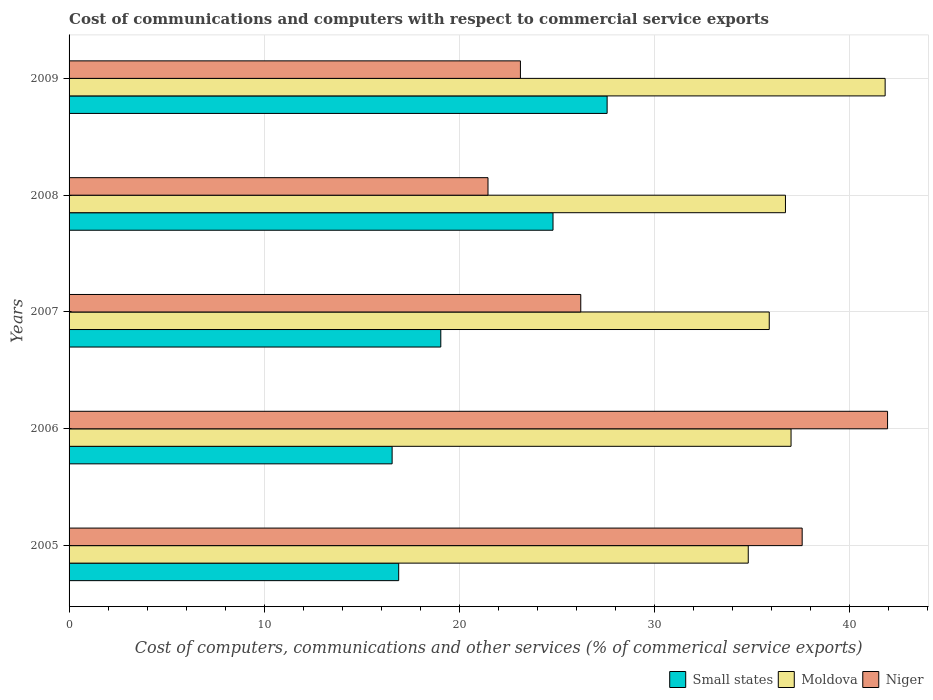How many different coloured bars are there?
Make the answer very short. 3. How many bars are there on the 3rd tick from the top?
Provide a short and direct response. 3. How many bars are there on the 4th tick from the bottom?
Make the answer very short. 3. What is the label of the 2nd group of bars from the top?
Provide a short and direct response. 2008. In how many cases, is the number of bars for a given year not equal to the number of legend labels?
Your response must be concise. 0. What is the cost of communications and computers in Niger in 2005?
Provide a succinct answer. 37.59. Across all years, what is the maximum cost of communications and computers in Moldova?
Give a very brief answer. 41.84. Across all years, what is the minimum cost of communications and computers in Niger?
Provide a succinct answer. 21.48. In which year was the cost of communications and computers in Small states maximum?
Provide a short and direct response. 2009. What is the total cost of communications and computers in Niger in the graph?
Make the answer very short. 150.41. What is the difference between the cost of communications and computers in Small states in 2008 and that in 2009?
Keep it short and to the point. -2.77. What is the difference between the cost of communications and computers in Small states in 2009 and the cost of communications and computers in Niger in 2007?
Keep it short and to the point. 1.35. What is the average cost of communications and computers in Small states per year?
Make the answer very short. 20.98. In the year 2007, what is the difference between the cost of communications and computers in Small states and cost of communications and computers in Niger?
Ensure brevity in your answer.  -7.18. What is the ratio of the cost of communications and computers in Small states in 2007 to that in 2009?
Provide a short and direct response. 0.69. What is the difference between the highest and the second highest cost of communications and computers in Small states?
Provide a short and direct response. 2.77. What is the difference between the highest and the lowest cost of communications and computers in Niger?
Provide a short and direct response. 20.49. In how many years, is the cost of communications and computers in Moldova greater than the average cost of communications and computers in Moldova taken over all years?
Your response must be concise. 1. Is the sum of the cost of communications and computers in Moldova in 2006 and 2009 greater than the maximum cost of communications and computers in Small states across all years?
Offer a terse response. Yes. What does the 1st bar from the top in 2006 represents?
Make the answer very short. Niger. What does the 3rd bar from the bottom in 2008 represents?
Provide a succinct answer. Niger. Is it the case that in every year, the sum of the cost of communications and computers in Moldova and cost of communications and computers in Small states is greater than the cost of communications and computers in Niger?
Offer a very short reply. Yes. Are all the bars in the graph horizontal?
Provide a short and direct response. Yes. What is the difference between two consecutive major ticks on the X-axis?
Make the answer very short. 10. Does the graph contain any zero values?
Your response must be concise. No. How many legend labels are there?
Offer a very short reply. 3. How are the legend labels stacked?
Make the answer very short. Horizontal. What is the title of the graph?
Offer a very short reply. Cost of communications and computers with respect to commercial service exports. Does "St. Martin (French part)" appear as one of the legend labels in the graph?
Provide a succinct answer. No. What is the label or title of the X-axis?
Provide a short and direct response. Cost of computers, communications and other services (% of commerical service exports). What is the label or title of the Y-axis?
Offer a terse response. Years. What is the Cost of computers, communications and other services (% of commerical service exports) in Small states in 2005?
Your response must be concise. 16.9. What is the Cost of computers, communications and other services (% of commerical service exports) of Moldova in 2005?
Ensure brevity in your answer.  34.82. What is the Cost of computers, communications and other services (% of commerical service exports) of Niger in 2005?
Your response must be concise. 37.59. What is the Cost of computers, communications and other services (% of commerical service exports) of Small states in 2006?
Make the answer very short. 16.56. What is the Cost of computers, communications and other services (% of commerical service exports) in Moldova in 2006?
Keep it short and to the point. 37.02. What is the Cost of computers, communications and other services (% of commerical service exports) in Niger in 2006?
Your answer should be compact. 41.97. What is the Cost of computers, communications and other services (% of commerical service exports) in Small states in 2007?
Your response must be concise. 19.06. What is the Cost of computers, communications and other services (% of commerical service exports) in Moldova in 2007?
Your answer should be compact. 35.9. What is the Cost of computers, communications and other services (% of commerical service exports) in Niger in 2007?
Give a very brief answer. 26.24. What is the Cost of computers, communications and other services (% of commerical service exports) in Small states in 2008?
Provide a short and direct response. 24.81. What is the Cost of computers, communications and other services (% of commerical service exports) of Moldova in 2008?
Your answer should be very brief. 36.73. What is the Cost of computers, communications and other services (% of commerical service exports) of Niger in 2008?
Give a very brief answer. 21.48. What is the Cost of computers, communications and other services (% of commerical service exports) in Small states in 2009?
Provide a succinct answer. 27.59. What is the Cost of computers, communications and other services (% of commerical service exports) in Moldova in 2009?
Your answer should be very brief. 41.84. What is the Cost of computers, communications and other services (% of commerical service exports) in Niger in 2009?
Your response must be concise. 23.14. Across all years, what is the maximum Cost of computers, communications and other services (% of commerical service exports) in Small states?
Offer a very short reply. 27.59. Across all years, what is the maximum Cost of computers, communications and other services (% of commerical service exports) in Moldova?
Keep it short and to the point. 41.84. Across all years, what is the maximum Cost of computers, communications and other services (% of commerical service exports) in Niger?
Make the answer very short. 41.97. Across all years, what is the minimum Cost of computers, communications and other services (% of commerical service exports) in Small states?
Your answer should be compact. 16.56. Across all years, what is the minimum Cost of computers, communications and other services (% of commerical service exports) of Moldova?
Your answer should be very brief. 34.82. Across all years, what is the minimum Cost of computers, communications and other services (% of commerical service exports) of Niger?
Your response must be concise. 21.48. What is the total Cost of computers, communications and other services (% of commerical service exports) of Small states in the graph?
Offer a terse response. 104.92. What is the total Cost of computers, communications and other services (% of commerical service exports) in Moldova in the graph?
Make the answer very short. 186.31. What is the total Cost of computers, communications and other services (% of commerical service exports) in Niger in the graph?
Provide a short and direct response. 150.41. What is the difference between the Cost of computers, communications and other services (% of commerical service exports) in Small states in 2005 and that in 2006?
Offer a terse response. 0.34. What is the difference between the Cost of computers, communications and other services (% of commerical service exports) of Moldova in 2005 and that in 2006?
Give a very brief answer. -2.19. What is the difference between the Cost of computers, communications and other services (% of commerical service exports) in Niger in 2005 and that in 2006?
Keep it short and to the point. -4.38. What is the difference between the Cost of computers, communications and other services (% of commerical service exports) in Small states in 2005 and that in 2007?
Offer a terse response. -2.16. What is the difference between the Cost of computers, communications and other services (% of commerical service exports) of Moldova in 2005 and that in 2007?
Give a very brief answer. -1.08. What is the difference between the Cost of computers, communications and other services (% of commerical service exports) in Niger in 2005 and that in 2007?
Your response must be concise. 11.35. What is the difference between the Cost of computers, communications and other services (% of commerical service exports) of Small states in 2005 and that in 2008?
Give a very brief answer. -7.91. What is the difference between the Cost of computers, communications and other services (% of commerical service exports) of Moldova in 2005 and that in 2008?
Provide a succinct answer. -1.91. What is the difference between the Cost of computers, communications and other services (% of commerical service exports) in Niger in 2005 and that in 2008?
Make the answer very short. 16.11. What is the difference between the Cost of computers, communications and other services (% of commerical service exports) of Small states in 2005 and that in 2009?
Keep it short and to the point. -10.69. What is the difference between the Cost of computers, communications and other services (% of commerical service exports) in Moldova in 2005 and that in 2009?
Your answer should be compact. -7.02. What is the difference between the Cost of computers, communications and other services (% of commerical service exports) in Niger in 2005 and that in 2009?
Offer a terse response. 14.45. What is the difference between the Cost of computers, communications and other services (% of commerical service exports) in Small states in 2006 and that in 2007?
Ensure brevity in your answer.  -2.5. What is the difference between the Cost of computers, communications and other services (% of commerical service exports) in Moldova in 2006 and that in 2007?
Give a very brief answer. 1.12. What is the difference between the Cost of computers, communications and other services (% of commerical service exports) in Niger in 2006 and that in 2007?
Offer a very short reply. 15.73. What is the difference between the Cost of computers, communications and other services (% of commerical service exports) of Small states in 2006 and that in 2008?
Make the answer very short. -8.25. What is the difference between the Cost of computers, communications and other services (% of commerical service exports) of Moldova in 2006 and that in 2008?
Your answer should be compact. 0.29. What is the difference between the Cost of computers, communications and other services (% of commerical service exports) of Niger in 2006 and that in 2008?
Your response must be concise. 20.49. What is the difference between the Cost of computers, communications and other services (% of commerical service exports) in Small states in 2006 and that in 2009?
Offer a terse response. -11.02. What is the difference between the Cost of computers, communications and other services (% of commerical service exports) of Moldova in 2006 and that in 2009?
Your answer should be compact. -4.82. What is the difference between the Cost of computers, communications and other services (% of commerical service exports) of Niger in 2006 and that in 2009?
Provide a succinct answer. 18.82. What is the difference between the Cost of computers, communications and other services (% of commerical service exports) in Small states in 2007 and that in 2008?
Your answer should be very brief. -5.75. What is the difference between the Cost of computers, communications and other services (% of commerical service exports) of Moldova in 2007 and that in 2008?
Your answer should be compact. -0.83. What is the difference between the Cost of computers, communications and other services (% of commerical service exports) of Niger in 2007 and that in 2008?
Your answer should be compact. 4.76. What is the difference between the Cost of computers, communications and other services (% of commerical service exports) in Small states in 2007 and that in 2009?
Ensure brevity in your answer.  -8.53. What is the difference between the Cost of computers, communications and other services (% of commerical service exports) of Moldova in 2007 and that in 2009?
Your answer should be compact. -5.94. What is the difference between the Cost of computers, communications and other services (% of commerical service exports) in Niger in 2007 and that in 2009?
Keep it short and to the point. 3.09. What is the difference between the Cost of computers, communications and other services (% of commerical service exports) in Small states in 2008 and that in 2009?
Keep it short and to the point. -2.77. What is the difference between the Cost of computers, communications and other services (% of commerical service exports) of Moldova in 2008 and that in 2009?
Your response must be concise. -5.11. What is the difference between the Cost of computers, communications and other services (% of commerical service exports) of Niger in 2008 and that in 2009?
Your response must be concise. -1.66. What is the difference between the Cost of computers, communications and other services (% of commerical service exports) in Small states in 2005 and the Cost of computers, communications and other services (% of commerical service exports) in Moldova in 2006?
Keep it short and to the point. -20.12. What is the difference between the Cost of computers, communications and other services (% of commerical service exports) in Small states in 2005 and the Cost of computers, communications and other services (% of commerical service exports) in Niger in 2006?
Give a very brief answer. -25.07. What is the difference between the Cost of computers, communications and other services (% of commerical service exports) of Moldova in 2005 and the Cost of computers, communications and other services (% of commerical service exports) of Niger in 2006?
Make the answer very short. -7.14. What is the difference between the Cost of computers, communications and other services (% of commerical service exports) of Small states in 2005 and the Cost of computers, communications and other services (% of commerical service exports) of Moldova in 2007?
Make the answer very short. -19. What is the difference between the Cost of computers, communications and other services (% of commerical service exports) of Small states in 2005 and the Cost of computers, communications and other services (% of commerical service exports) of Niger in 2007?
Provide a succinct answer. -9.34. What is the difference between the Cost of computers, communications and other services (% of commerical service exports) of Moldova in 2005 and the Cost of computers, communications and other services (% of commerical service exports) of Niger in 2007?
Keep it short and to the point. 8.59. What is the difference between the Cost of computers, communications and other services (% of commerical service exports) of Small states in 2005 and the Cost of computers, communications and other services (% of commerical service exports) of Moldova in 2008?
Make the answer very short. -19.83. What is the difference between the Cost of computers, communications and other services (% of commerical service exports) of Small states in 2005 and the Cost of computers, communications and other services (% of commerical service exports) of Niger in 2008?
Offer a very short reply. -4.58. What is the difference between the Cost of computers, communications and other services (% of commerical service exports) of Moldova in 2005 and the Cost of computers, communications and other services (% of commerical service exports) of Niger in 2008?
Make the answer very short. 13.34. What is the difference between the Cost of computers, communications and other services (% of commerical service exports) of Small states in 2005 and the Cost of computers, communications and other services (% of commerical service exports) of Moldova in 2009?
Your response must be concise. -24.94. What is the difference between the Cost of computers, communications and other services (% of commerical service exports) of Small states in 2005 and the Cost of computers, communications and other services (% of commerical service exports) of Niger in 2009?
Your answer should be very brief. -6.24. What is the difference between the Cost of computers, communications and other services (% of commerical service exports) in Moldova in 2005 and the Cost of computers, communications and other services (% of commerical service exports) in Niger in 2009?
Provide a short and direct response. 11.68. What is the difference between the Cost of computers, communications and other services (% of commerical service exports) of Small states in 2006 and the Cost of computers, communications and other services (% of commerical service exports) of Moldova in 2007?
Your answer should be very brief. -19.34. What is the difference between the Cost of computers, communications and other services (% of commerical service exports) in Small states in 2006 and the Cost of computers, communications and other services (% of commerical service exports) in Niger in 2007?
Keep it short and to the point. -9.67. What is the difference between the Cost of computers, communications and other services (% of commerical service exports) in Moldova in 2006 and the Cost of computers, communications and other services (% of commerical service exports) in Niger in 2007?
Make the answer very short. 10.78. What is the difference between the Cost of computers, communications and other services (% of commerical service exports) of Small states in 2006 and the Cost of computers, communications and other services (% of commerical service exports) of Moldova in 2008?
Keep it short and to the point. -20.17. What is the difference between the Cost of computers, communications and other services (% of commerical service exports) in Small states in 2006 and the Cost of computers, communications and other services (% of commerical service exports) in Niger in 2008?
Your answer should be very brief. -4.92. What is the difference between the Cost of computers, communications and other services (% of commerical service exports) in Moldova in 2006 and the Cost of computers, communications and other services (% of commerical service exports) in Niger in 2008?
Make the answer very short. 15.54. What is the difference between the Cost of computers, communications and other services (% of commerical service exports) in Small states in 2006 and the Cost of computers, communications and other services (% of commerical service exports) in Moldova in 2009?
Provide a succinct answer. -25.28. What is the difference between the Cost of computers, communications and other services (% of commerical service exports) of Small states in 2006 and the Cost of computers, communications and other services (% of commerical service exports) of Niger in 2009?
Your answer should be compact. -6.58. What is the difference between the Cost of computers, communications and other services (% of commerical service exports) in Moldova in 2006 and the Cost of computers, communications and other services (% of commerical service exports) in Niger in 2009?
Provide a succinct answer. 13.88. What is the difference between the Cost of computers, communications and other services (% of commerical service exports) of Small states in 2007 and the Cost of computers, communications and other services (% of commerical service exports) of Moldova in 2008?
Keep it short and to the point. -17.67. What is the difference between the Cost of computers, communications and other services (% of commerical service exports) in Small states in 2007 and the Cost of computers, communications and other services (% of commerical service exports) in Niger in 2008?
Keep it short and to the point. -2.42. What is the difference between the Cost of computers, communications and other services (% of commerical service exports) of Moldova in 2007 and the Cost of computers, communications and other services (% of commerical service exports) of Niger in 2008?
Offer a very short reply. 14.42. What is the difference between the Cost of computers, communications and other services (% of commerical service exports) of Small states in 2007 and the Cost of computers, communications and other services (% of commerical service exports) of Moldova in 2009?
Provide a short and direct response. -22.78. What is the difference between the Cost of computers, communications and other services (% of commerical service exports) in Small states in 2007 and the Cost of computers, communications and other services (% of commerical service exports) in Niger in 2009?
Ensure brevity in your answer.  -4.08. What is the difference between the Cost of computers, communications and other services (% of commerical service exports) of Moldova in 2007 and the Cost of computers, communications and other services (% of commerical service exports) of Niger in 2009?
Your answer should be very brief. 12.76. What is the difference between the Cost of computers, communications and other services (% of commerical service exports) of Small states in 2008 and the Cost of computers, communications and other services (% of commerical service exports) of Moldova in 2009?
Your response must be concise. -17.03. What is the difference between the Cost of computers, communications and other services (% of commerical service exports) of Small states in 2008 and the Cost of computers, communications and other services (% of commerical service exports) of Niger in 2009?
Your answer should be compact. 1.67. What is the difference between the Cost of computers, communications and other services (% of commerical service exports) of Moldova in 2008 and the Cost of computers, communications and other services (% of commerical service exports) of Niger in 2009?
Ensure brevity in your answer.  13.59. What is the average Cost of computers, communications and other services (% of commerical service exports) of Small states per year?
Your answer should be very brief. 20.98. What is the average Cost of computers, communications and other services (% of commerical service exports) in Moldova per year?
Your answer should be very brief. 37.26. What is the average Cost of computers, communications and other services (% of commerical service exports) of Niger per year?
Your answer should be very brief. 30.08. In the year 2005, what is the difference between the Cost of computers, communications and other services (% of commerical service exports) of Small states and Cost of computers, communications and other services (% of commerical service exports) of Moldova?
Provide a short and direct response. -17.92. In the year 2005, what is the difference between the Cost of computers, communications and other services (% of commerical service exports) of Small states and Cost of computers, communications and other services (% of commerical service exports) of Niger?
Make the answer very short. -20.69. In the year 2005, what is the difference between the Cost of computers, communications and other services (% of commerical service exports) of Moldova and Cost of computers, communications and other services (% of commerical service exports) of Niger?
Ensure brevity in your answer.  -2.76. In the year 2006, what is the difference between the Cost of computers, communications and other services (% of commerical service exports) in Small states and Cost of computers, communications and other services (% of commerical service exports) in Moldova?
Provide a succinct answer. -20.45. In the year 2006, what is the difference between the Cost of computers, communications and other services (% of commerical service exports) of Small states and Cost of computers, communications and other services (% of commerical service exports) of Niger?
Your answer should be very brief. -25.4. In the year 2006, what is the difference between the Cost of computers, communications and other services (% of commerical service exports) in Moldova and Cost of computers, communications and other services (% of commerical service exports) in Niger?
Your response must be concise. -4.95. In the year 2007, what is the difference between the Cost of computers, communications and other services (% of commerical service exports) in Small states and Cost of computers, communications and other services (% of commerical service exports) in Moldova?
Provide a succinct answer. -16.84. In the year 2007, what is the difference between the Cost of computers, communications and other services (% of commerical service exports) of Small states and Cost of computers, communications and other services (% of commerical service exports) of Niger?
Keep it short and to the point. -7.18. In the year 2007, what is the difference between the Cost of computers, communications and other services (% of commerical service exports) in Moldova and Cost of computers, communications and other services (% of commerical service exports) in Niger?
Provide a succinct answer. 9.66. In the year 2008, what is the difference between the Cost of computers, communications and other services (% of commerical service exports) of Small states and Cost of computers, communications and other services (% of commerical service exports) of Moldova?
Your answer should be compact. -11.92. In the year 2008, what is the difference between the Cost of computers, communications and other services (% of commerical service exports) of Small states and Cost of computers, communications and other services (% of commerical service exports) of Niger?
Provide a short and direct response. 3.33. In the year 2008, what is the difference between the Cost of computers, communications and other services (% of commerical service exports) of Moldova and Cost of computers, communications and other services (% of commerical service exports) of Niger?
Offer a terse response. 15.25. In the year 2009, what is the difference between the Cost of computers, communications and other services (% of commerical service exports) in Small states and Cost of computers, communications and other services (% of commerical service exports) in Moldova?
Offer a terse response. -14.25. In the year 2009, what is the difference between the Cost of computers, communications and other services (% of commerical service exports) in Small states and Cost of computers, communications and other services (% of commerical service exports) in Niger?
Give a very brief answer. 4.45. In the year 2009, what is the difference between the Cost of computers, communications and other services (% of commerical service exports) of Moldova and Cost of computers, communications and other services (% of commerical service exports) of Niger?
Your response must be concise. 18.7. What is the ratio of the Cost of computers, communications and other services (% of commerical service exports) of Small states in 2005 to that in 2006?
Keep it short and to the point. 1.02. What is the ratio of the Cost of computers, communications and other services (% of commerical service exports) in Moldova in 2005 to that in 2006?
Provide a succinct answer. 0.94. What is the ratio of the Cost of computers, communications and other services (% of commerical service exports) of Niger in 2005 to that in 2006?
Keep it short and to the point. 0.9. What is the ratio of the Cost of computers, communications and other services (% of commerical service exports) of Small states in 2005 to that in 2007?
Give a very brief answer. 0.89. What is the ratio of the Cost of computers, communications and other services (% of commerical service exports) in Moldova in 2005 to that in 2007?
Provide a short and direct response. 0.97. What is the ratio of the Cost of computers, communications and other services (% of commerical service exports) in Niger in 2005 to that in 2007?
Your answer should be compact. 1.43. What is the ratio of the Cost of computers, communications and other services (% of commerical service exports) of Small states in 2005 to that in 2008?
Provide a succinct answer. 0.68. What is the ratio of the Cost of computers, communications and other services (% of commerical service exports) of Moldova in 2005 to that in 2008?
Provide a short and direct response. 0.95. What is the ratio of the Cost of computers, communications and other services (% of commerical service exports) in Niger in 2005 to that in 2008?
Provide a succinct answer. 1.75. What is the ratio of the Cost of computers, communications and other services (% of commerical service exports) of Small states in 2005 to that in 2009?
Make the answer very short. 0.61. What is the ratio of the Cost of computers, communications and other services (% of commerical service exports) of Moldova in 2005 to that in 2009?
Keep it short and to the point. 0.83. What is the ratio of the Cost of computers, communications and other services (% of commerical service exports) of Niger in 2005 to that in 2009?
Give a very brief answer. 1.62. What is the ratio of the Cost of computers, communications and other services (% of commerical service exports) of Small states in 2006 to that in 2007?
Your answer should be very brief. 0.87. What is the ratio of the Cost of computers, communications and other services (% of commerical service exports) of Moldova in 2006 to that in 2007?
Give a very brief answer. 1.03. What is the ratio of the Cost of computers, communications and other services (% of commerical service exports) in Niger in 2006 to that in 2007?
Make the answer very short. 1.6. What is the ratio of the Cost of computers, communications and other services (% of commerical service exports) of Small states in 2006 to that in 2008?
Offer a terse response. 0.67. What is the ratio of the Cost of computers, communications and other services (% of commerical service exports) of Niger in 2006 to that in 2008?
Keep it short and to the point. 1.95. What is the ratio of the Cost of computers, communications and other services (% of commerical service exports) of Small states in 2006 to that in 2009?
Keep it short and to the point. 0.6. What is the ratio of the Cost of computers, communications and other services (% of commerical service exports) of Moldova in 2006 to that in 2009?
Your answer should be very brief. 0.88. What is the ratio of the Cost of computers, communications and other services (% of commerical service exports) of Niger in 2006 to that in 2009?
Make the answer very short. 1.81. What is the ratio of the Cost of computers, communications and other services (% of commerical service exports) in Small states in 2007 to that in 2008?
Make the answer very short. 0.77. What is the ratio of the Cost of computers, communications and other services (% of commerical service exports) in Moldova in 2007 to that in 2008?
Provide a succinct answer. 0.98. What is the ratio of the Cost of computers, communications and other services (% of commerical service exports) of Niger in 2007 to that in 2008?
Offer a very short reply. 1.22. What is the ratio of the Cost of computers, communications and other services (% of commerical service exports) in Small states in 2007 to that in 2009?
Provide a short and direct response. 0.69. What is the ratio of the Cost of computers, communications and other services (% of commerical service exports) in Moldova in 2007 to that in 2009?
Provide a succinct answer. 0.86. What is the ratio of the Cost of computers, communications and other services (% of commerical service exports) of Niger in 2007 to that in 2009?
Your answer should be compact. 1.13. What is the ratio of the Cost of computers, communications and other services (% of commerical service exports) of Small states in 2008 to that in 2009?
Offer a terse response. 0.9. What is the ratio of the Cost of computers, communications and other services (% of commerical service exports) in Moldova in 2008 to that in 2009?
Offer a terse response. 0.88. What is the ratio of the Cost of computers, communications and other services (% of commerical service exports) of Niger in 2008 to that in 2009?
Offer a very short reply. 0.93. What is the difference between the highest and the second highest Cost of computers, communications and other services (% of commerical service exports) of Small states?
Keep it short and to the point. 2.77. What is the difference between the highest and the second highest Cost of computers, communications and other services (% of commerical service exports) of Moldova?
Provide a succinct answer. 4.82. What is the difference between the highest and the second highest Cost of computers, communications and other services (% of commerical service exports) in Niger?
Offer a terse response. 4.38. What is the difference between the highest and the lowest Cost of computers, communications and other services (% of commerical service exports) in Small states?
Provide a short and direct response. 11.02. What is the difference between the highest and the lowest Cost of computers, communications and other services (% of commerical service exports) in Moldova?
Keep it short and to the point. 7.02. What is the difference between the highest and the lowest Cost of computers, communications and other services (% of commerical service exports) of Niger?
Your answer should be compact. 20.49. 